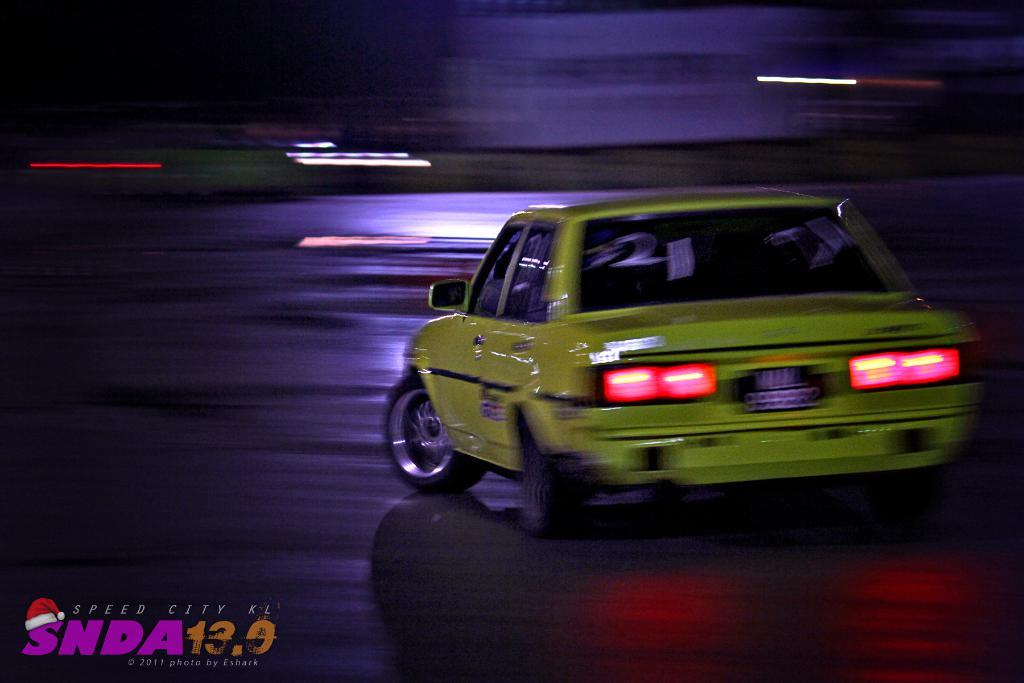What is the main subject of the image? The main subject of the image is a car. Where is the car located in the image? The car is on the road in the image. Is there any text present in the image? Yes, there is some text at the left side bottom of the image. Can you see any waves crashing on the shore in the image? There are no waves or shore visible in the image; it features a car on the road. Is there any exchange of currency happening in the image? There is no exchange of currency depicted in the image; it only shows a car on the road. 